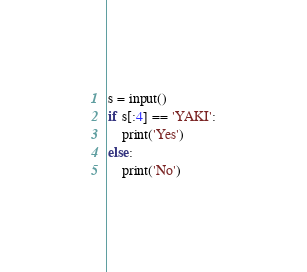Convert code to text. <code><loc_0><loc_0><loc_500><loc_500><_Python_>s = input()
if s[:4] == 'YAKI':
    print('Yes')
else:
    print('No')
</code> 